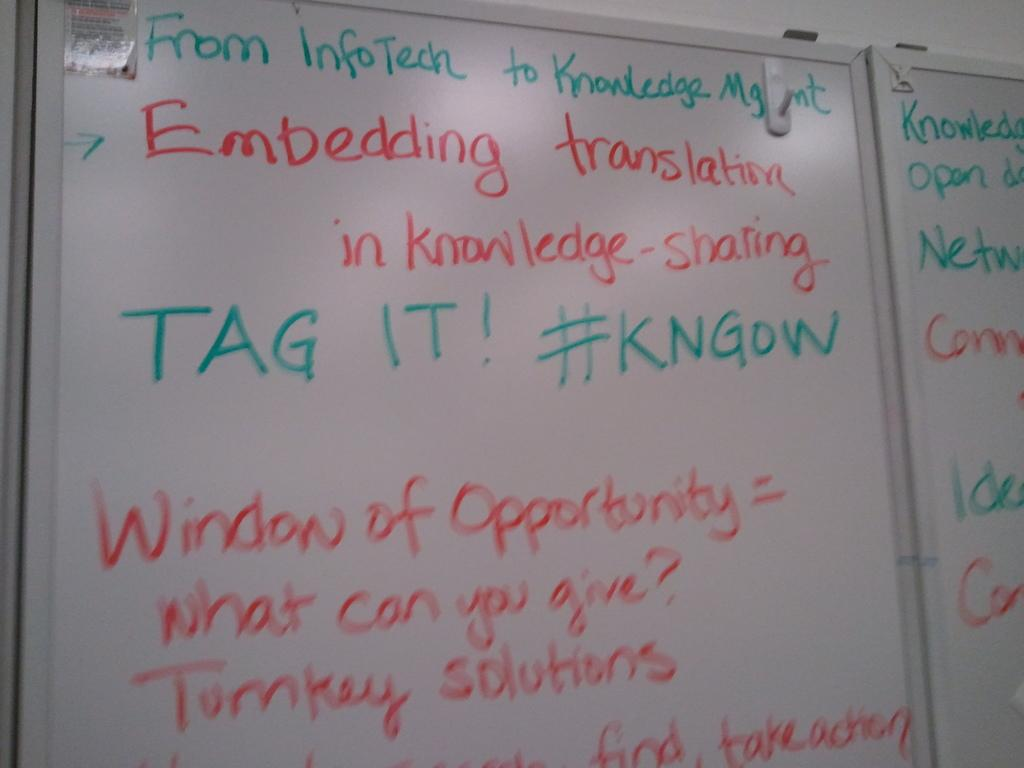<image>
Summarize the visual content of the image. A dry erase board has notes on it about embedding translation in knowledge sharing. 